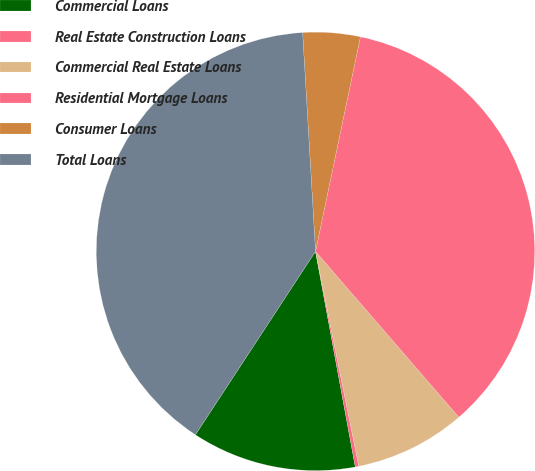Convert chart. <chart><loc_0><loc_0><loc_500><loc_500><pie_chart><fcel>Commercial Loans<fcel>Real Estate Construction Loans<fcel>Commercial Real Estate Loans<fcel>Residential Mortgage Loans<fcel>Consumer Loans<fcel>Total Loans<nl><fcel>12.13%<fcel>0.26%<fcel>8.18%<fcel>35.37%<fcel>4.22%<fcel>39.83%<nl></chart> 